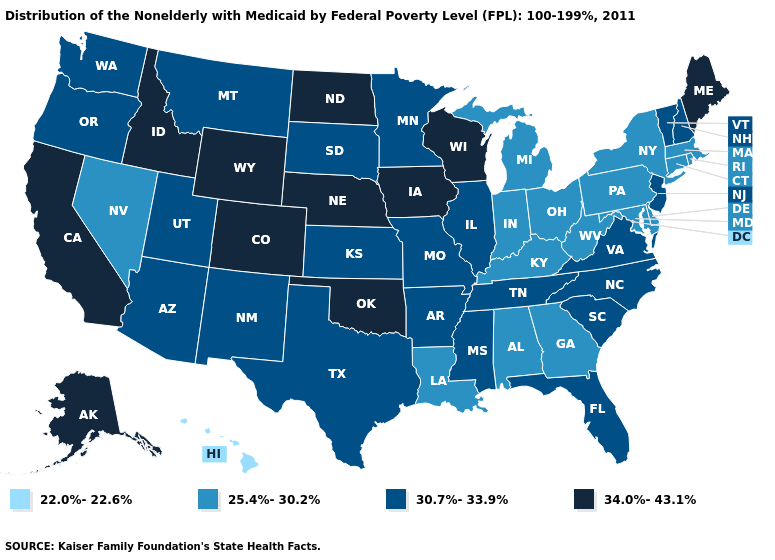What is the value of North Dakota?
Write a very short answer. 34.0%-43.1%. What is the value of Minnesota?
Quick response, please. 30.7%-33.9%. What is the value of California?
Quick response, please. 34.0%-43.1%. What is the value of Texas?
Quick response, please. 30.7%-33.9%. What is the highest value in states that border Washington?
Give a very brief answer. 34.0%-43.1%. Name the states that have a value in the range 34.0%-43.1%?
Answer briefly. Alaska, California, Colorado, Idaho, Iowa, Maine, Nebraska, North Dakota, Oklahoma, Wisconsin, Wyoming. What is the highest value in the USA?
Give a very brief answer. 34.0%-43.1%. Name the states that have a value in the range 22.0%-22.6%?
Be succinct. Hawaii. What is the value of South Carolina?
Concise answer only. 30.7%-33.9%. Name the states that have a value in the range 25.4%-30.2%?
Quick response, please. Alabama, Connecticut, Delaware, Georgia, Indiana, Kentucky, Louisiana, Maryland, Massachusetts, Michigan, Nevada, New York, Ohio, Pennsylvania, Rhode Island, West Virginia. What is the value of Idaho?
Be succinct. 34.0%-43.1%. Name the states that have a value in the range 22.0%-22.6%?
Keep it brief. Hawaii. Does Rhode Island have a lower value than Massachusetts?
Give a very brief answer. No. Among the states that border Minnesota , does South Dakota have the lowest value?
Concise answer only. Yes. Does Oklahoma have the same value as Oregon?
Short answer required. No. 